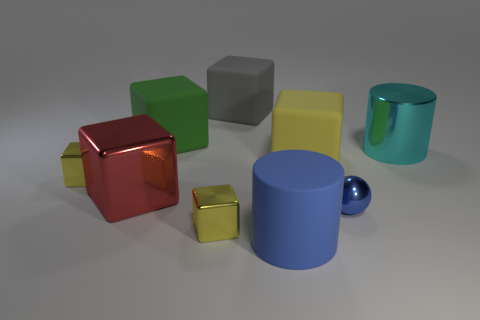Is the color of the small shiny sphere the same as the rubber cylinder?
Ensure brevity in your answer.  Yes. Is the material of the cylinder on the left side of the cyan object the same as the big cylinder behind the large yellow block?
Your answer should be very brief. No. There is a rubber cylinder that is the same color as the small ball; what is its size?
Provide a short and direct response. Large. There is a cylinder that is in front of the red block; what is its material?
Your answer should be compact. Rubber. There is a big rubber object that is in front of the yellow rubber object; does it have the same shape as the large shiny object that is right of the red block?
Offer a terse response. Yes. There is a thing that is the same color as the big rubber cylinder; what material is it?
Offer a very short reply. Metal. Are any tiny shiny things visible?
Offer a very short reply. Yes. There is a large yellow thing that is the same shape as the red thing; what material is it?
Ensure brevity in your answer.  Rubber. There is a gray rubber block; are there any yellow things to the left of it?
Your answer should be compact. Yes. Do the small sphere to the left of the big cyan thing and the cyan object have the same material?
Offer a terse response. Yes. 